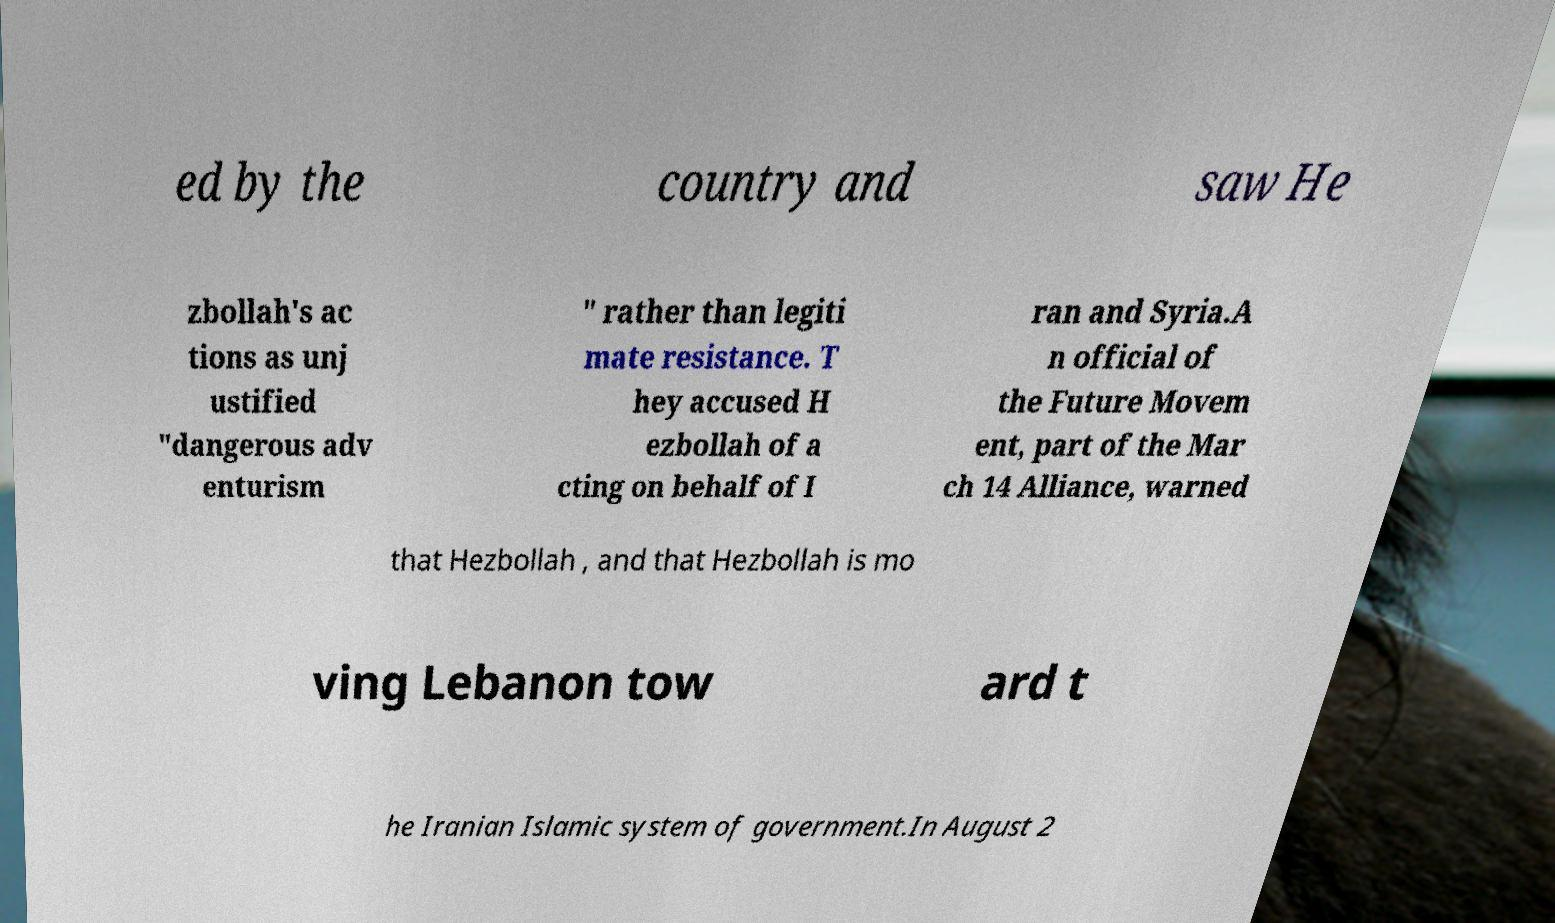For documentation purposes, I need the text within this image transcribed. Could you provide that? ed by the country and saw He zbollah's ac tions as unj ustified "dangerous adv enturism " rather than legiti mate resistance. T hey accused H ezbollah of a cting on behalf of I ran and Syria.A n official of the Future Movem ent, part of the Mar ch 14 Alliance, warned that Hezbollah , and that Hezbollah is mo ving Lebanon tow ard t he Iranian Islamic system of government.In August 2 